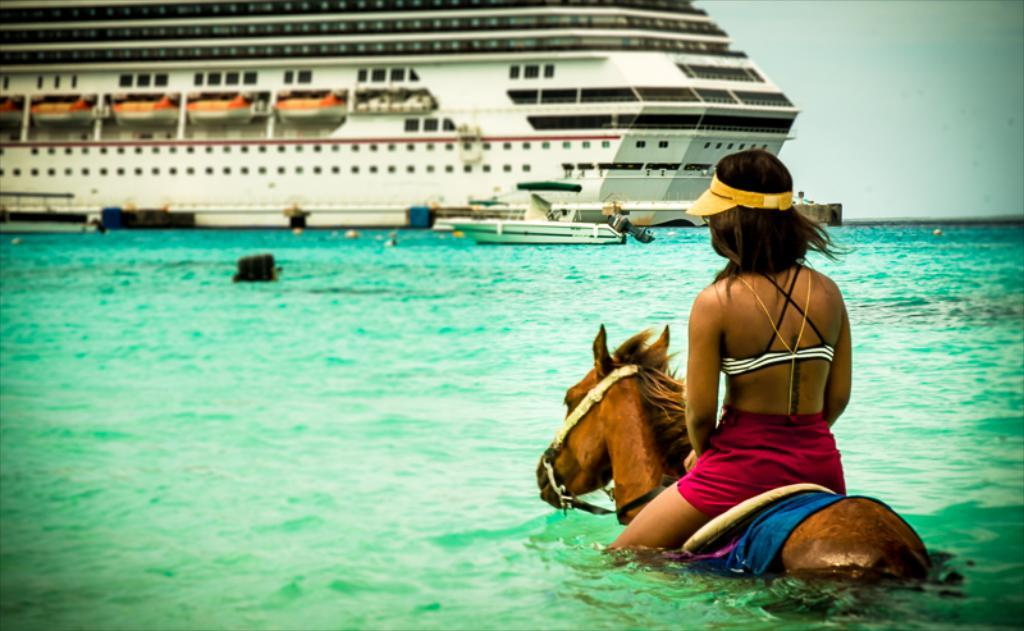What is the person doing in the image? The person is sitting on a horse. Where is the horse located in the image? The horse is in the water. What can be seen in the background of the image? There is a ship in the background. How many spiders are crawling on the bridge in the image? There is no bridge present in the image, and therefore no spiders can be observed. 